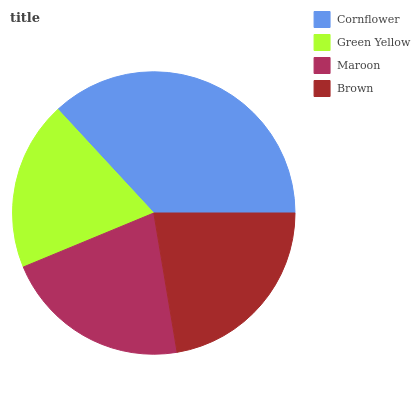Is Green Yellow the minimum?
Answer yes or no. Yes. Is Cornflower the maximum?
Answer yes or no. Yes. Is Maroon the minimum?
Answer yes or no. No. Is Maroon the maximum?
Answer yes or no. No. Is Maroon greater than Green Yellow?
Answer yes or no. Yes. Is Green Yellow less than Maroon?
Answer yes or no. Yes. Is Green Yellow greater than Maroon?
Answer yes or no. No. Is Maroon less than Green Yellow?
Answer yes or no. No. Is Brown the high median?
Answer yes or no. Yes. Is Maroon the low median?
Answer yes or no. Yes. Is Maroon the high median?
Answer yes or no. No. Is Cornflower the low median?
Answer yes or no. No. 